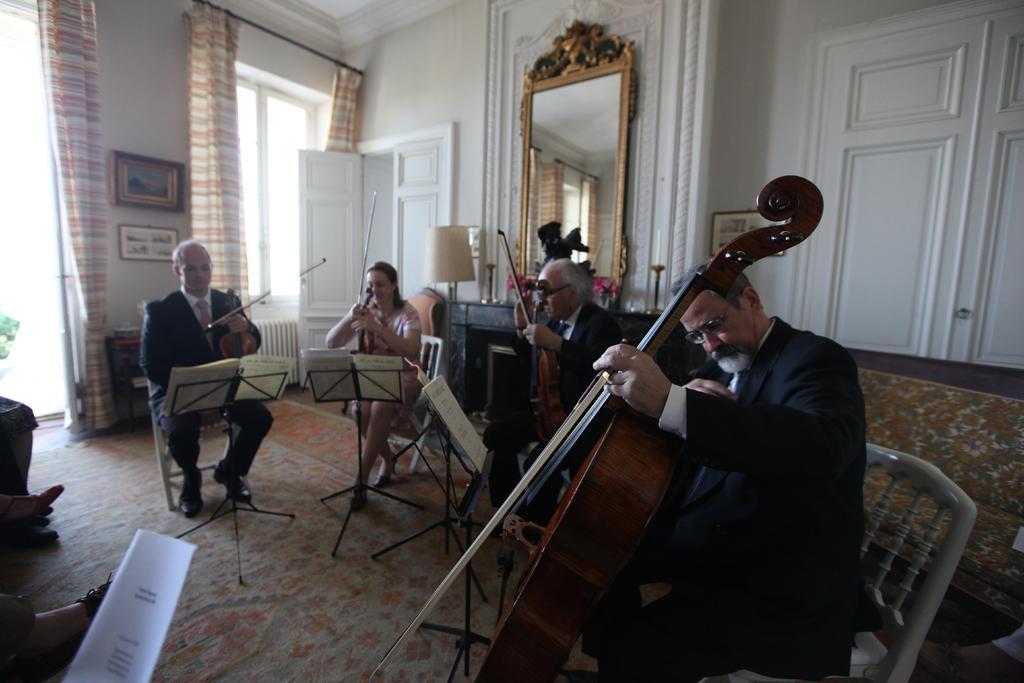How would you summarize this image in a sentence or two? In the image we can see there are people who are sitting and they are holding a violin in their hand. 